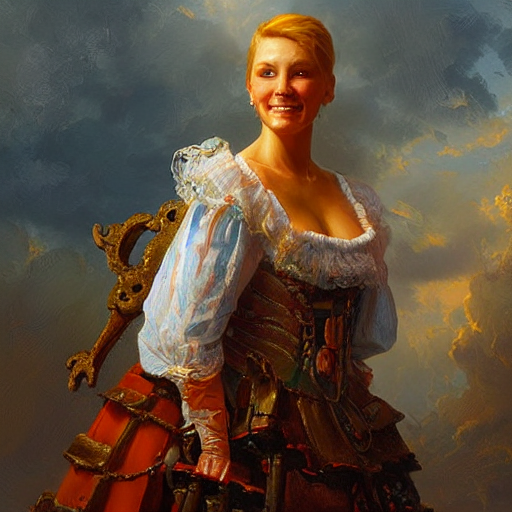Could you describe the attire of the person in the image? Certainly! The person in the image is wearing a historical costume, possibly inspired by the Renaissance. She has on a fitted corset with ornate detailing, over which a sheer, puffed-sleeve blouse is worn. The corset is a rich, rusty red, which complements the earthy tones of the background. Her overall attire gives an air of elegance and nobility. 